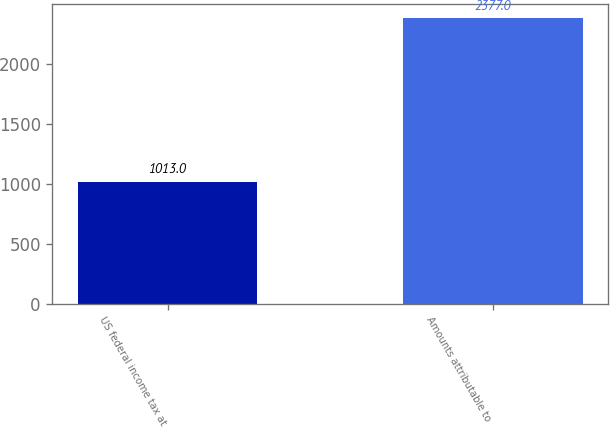Convert chart. <chart><loc_0><loc_0><loc_500><loc_500><bar_chart><fcel>US federal income tax at<fcel>Amounts attributable to<nl><fcel>1013<fcel>2377<nl></chart> 